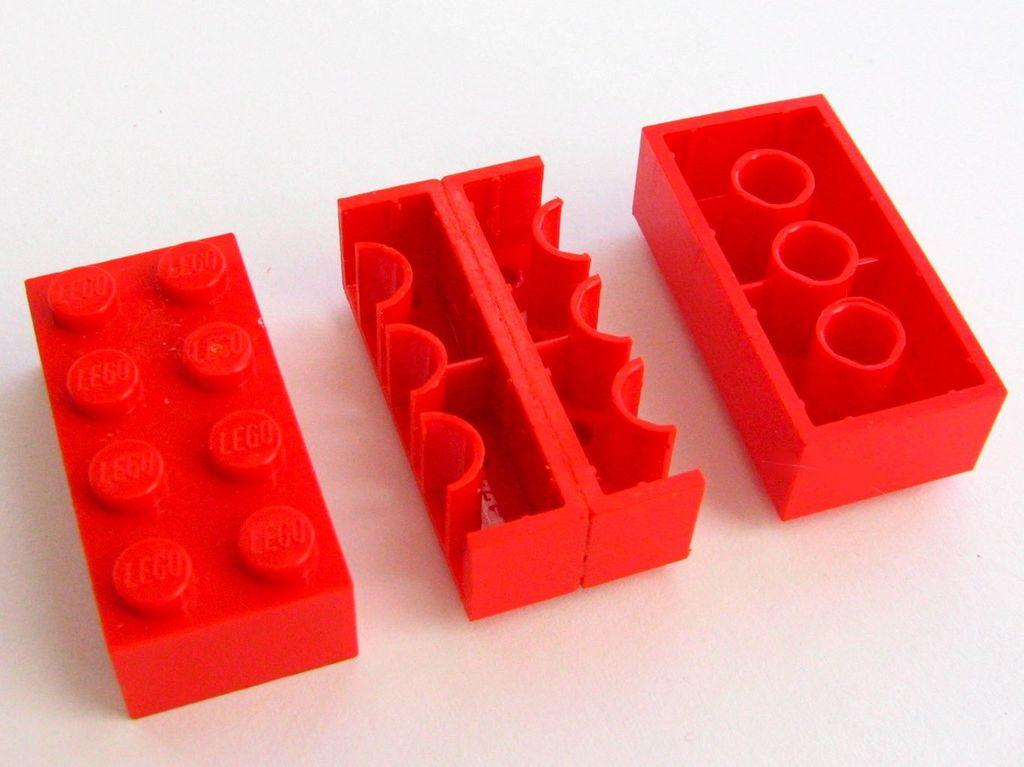What type of objects are in the image? There are red color building blocks in the image. Can you describe the color of the building blocks? The building blocks are red in color. How many rings of zinc are present in the image? There are no rings or zinc present in the image; it only features red color building blocks. 